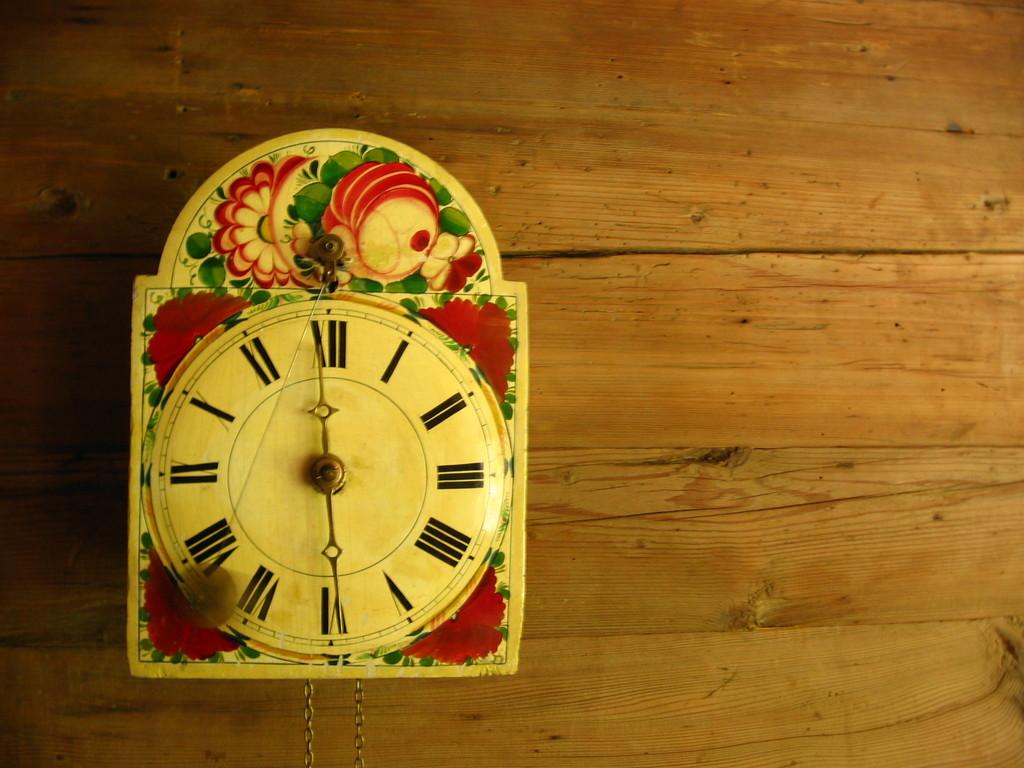What time does the clock show?
Provide a short and direct response. 12:30. 